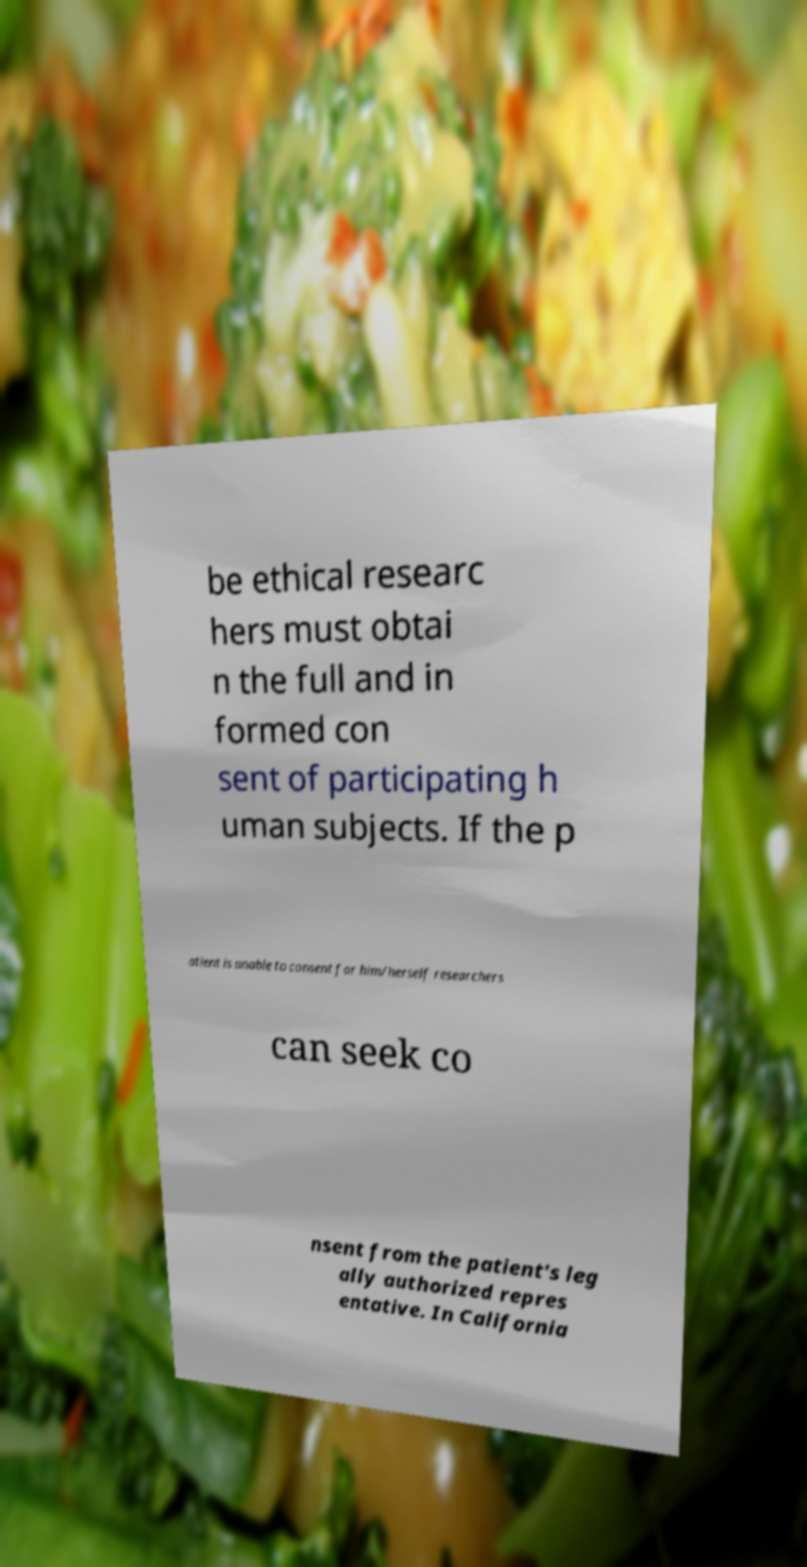Could you assist in decoding the text presented in this image and type it out clearly? be ethical researc hers must obtai n the full and in formed con sent of participating h uman subjects. If the p atient is unable to consent for him/herself researchers can seek co nsent from the patient's leg ally authorized repres entative. In California 